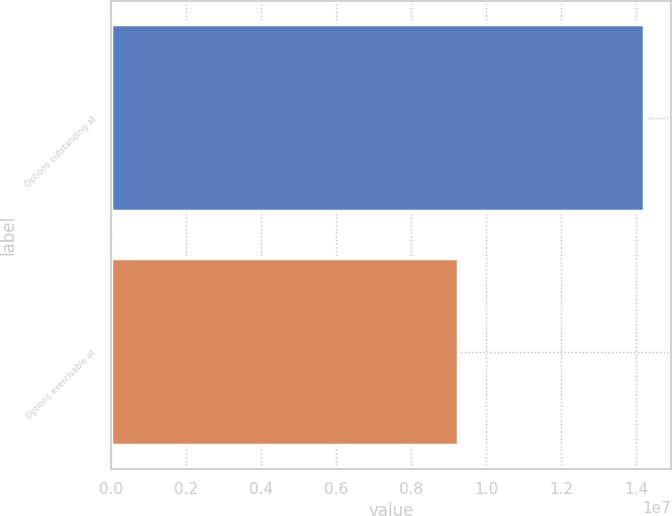Convert chart. <chart><loc_0><loc_0><loc_500><loc_500><bar_chart><fcel>Options outstanding at<fcel>Options exercisable at<nl><fcel>1.42171e+07<fcel>9.25682e+06<nl></chart> 